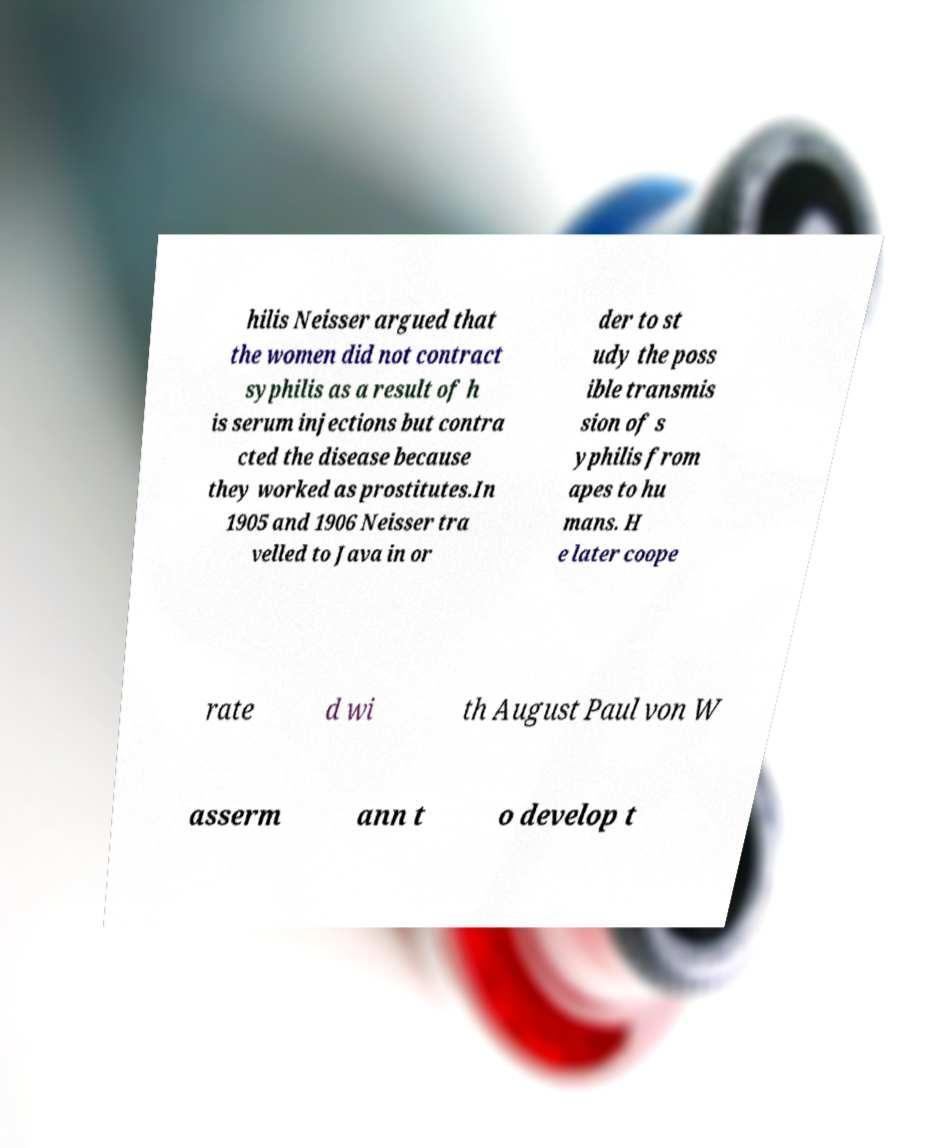Could you assist in decoding the text presented in this image and type it out clearly? hilis Neisser argued that the women did not contract syphilis as a result of h is serum injections but contra cted the disease because they worked as prostitutes.In 1905 and 1906 Neisser tra velled to Java in or der to st udy the poss ible transmis sion of s yphilis from apes to hu mans. H e later coope rate d wi th August Paul von W asserm ann t o develop t 